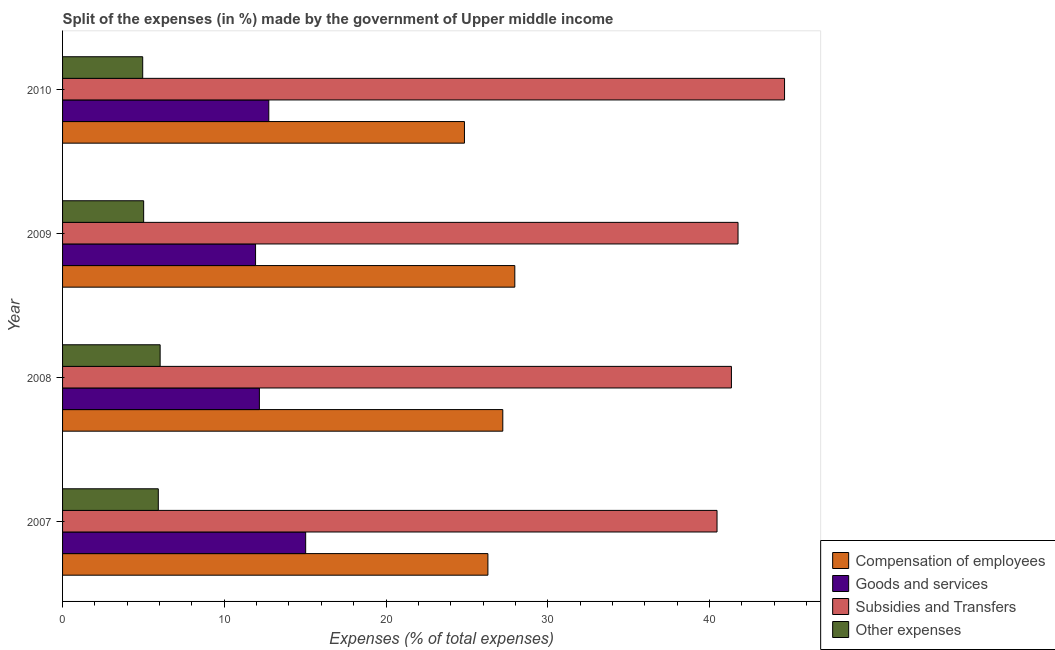How many different coloured bars are there?
Offer a terse response. 4. How many groups of bars are there?
Provide a short and direct response. 4. How many bars are there on the 2nd tick from the bottom?
Offer a terse response. 4. What is the label of the 1st group of bars from the top?
Ensure brevity in your answer.  2010. What is the percentage of amount spent on other expenses in 2008?
Ensure brevity in your answer.  6.03. Across all years, what is the maximum percentage of amount spent on compensation of employees?
Offer a very short reply. 27.96. Across all years, what is the minimum percentage of amount spent on compensation of employees?
Your response must be concise. 24.85. In which year was the percentage of amount spent on goods and services maximum?
Your answer should be very brief. 2007. What is the total percentage of amount spent on goods and services in the graph?
Provide a short and direct response. 51.89. What is the difference between the percentage of amount spent on compensation of employees in 2007 and that in 2010?
Provide a short and direct response. 1.45. What is the difference between the percentage of amount spent on goods and services in 2010 and the percentage of amount spent on other expenses in 2009?
Make the answer very short. 7.74. What is the average percentage of amount spent on compensation of employees per year?
Keep it short and to the point. 26.58. In the year 2007, what is the difference between the percentage of amount spent on goods and services and percentage of amount spent on subsidies?
Give a very brief answer. -25.43. In how many years, is the percentage of amount spent on other expenses greater than 38 %?
Provide a short and direct response. 0. What is the ratio of the percentage of amount spent on goods and services in 2008 to that in 2009?
Your response must be concise. 1.02. Is the difference between the percentage of amount spent on other expenses in 2008 and 2010 greater than the difference between the percentage of amount spent on compensation of employees in 2008 and 2010?
Your answer should be compact. No. What is the difference between the highest and the second highest percentage of amount spent on other expenses?
Give a very brief answer. 0.11. What is the difference between the highest and the lowest percentage of amount spent on compensation of employees?
Your answer should be compact. 3.11. Is the sum of the percentage of amount spent on subsidies in 2007 and 2010 greater than the maximum percentage of amount spent on other expenses across all years?
Your answer should be compact. Yes. Is it the case that in every year, the sum of the percentage of amount spent on goods and services and percentage of amount spent on subsidies is greater than the sum of percentage of amount spent on other expenses and percentage of amount spent on compensation of employees?
Provide a short and direct response. Yes. What does the 4th bar from the top in 2009 represents?
Make the answer very short. Compensation of employees. What does the 4th bar from the bottom in 2009 represents?
Offer a very short reply. Other expenses. How many bars are there?
Your answer should be very brief. 16. Does the graph contain any zero values?
Provide a short and direct response. No. Does the graph contain grids?
Your answer should be compact. No. Where does the legend appear in the graph?
Provide a succinct answer. Bottom right. How many legend labels are there?
Keep it short and to the point. 4. How are the legend labels stacked?
Provide a short and direct response. Vertical. What is the title of the graph?
Your response must be concise. Split of the expenses (in %) made by the government of Upper middle income. What is the label or title of the X-axis?
Offer a terse response. Expenses (% of total expenses). What is the Expenses (% of total expenses) of Compensation of employees in 2007?
Your response must be concise. 26.3. What is the Expenses (% of total expenses) in Goods and services in 2007?
Make the answer very short. 15.03. What is the Expenses (% of total expenses) of Subsidies and Transfers in 2007?
Your answer should be compact. 40.47. What is the Expenses (% of total expenses) in Other expenses in 2007?
Give a very brief answer. 5.92. What is the Expenses (% of total expenses) in Compensation of employees in 2008?
Keep it short and to the point. 27.22. What is the Expenses (% of total expenses) of Goods and services in 2008?
Provide a short and direct response. 12.17. What is the Expenses (% of total expenses) in Subsidies and Transfers in 2008?
Your answer should be compact. 41.36. What is the Expenses (% of total expenses) in Other expenses in 2008?
Offer a terse response. 6.03. What is the Expenses (% of total expenses) in Compensation of employees in 2009?
Offer a terse response. 27.96. What is the Expenses (% of total expenses) in Goods and services in 2009?
Make the answer very short. 11.93. What is the Expenses (% of total expenses) in Subsidies and Transfers in 2009?
Make the answer very short. 41.76. What is the Expenses (% of total expenses) of Other expenses in 2009?
Offer a terse response. 5.01. What is the Expenses (% of total expenses) of Compensation of employees in 2010?
Ensure brevity in your answer.  24.85. What is the Expenses (% of total expenses) in Goods and services in 2010?
Ensure brevity in your answer.  12.75. What is the Expenses (% of total expenses) in Subsidies and Transfers in 2010?
Your answer should be very brief. 44.64. What is the Expenses (% of total expenses) in Other expenses in 2010?
Offer a terse response. 4.96. Across all years, what is the maximum Expenses (% of total expenses) of Compensation of employees?
Offer a terse response. 27.96. Across all years, what is the maximum Expenses (% of total expenses) in Goods and services?
Give a very brief answer. 15.03. Across all years, what is the maximum Expenses (% of total expenses) in Subsidies and Transfers?
Your answer should be compact. 44.64. Across all years, what is the maximum Expenses (% of total expenses) in Other expenses?
Provide a succinct answer. 6.03. Across all years, what is the minimum Expenses (% of total expenses) of Compensation of employees?
Make the answer very short. 24.85. Across all years, what is the minimum Expenses (% of total expenses) in Goods and services?
Your answer should be compact. 11.93. Across all years, what is the minimum Expenses (% of total expenses) of Subsidies and Transfers?
Make the answer very short. 40.47. Across all years, what is the minimum Expenses (% of total expenses) of Other expenses?
Provide a short and direct response. 4.96. What is the total Expenses (% of total expenses) in Compensation of employees in the graph?
Offer a very short reply. 106.33. What is the total Expenses (% of total expenses) in Goods and services in the graph?
Ensure brevity in your answer.  51.89. What is the total Expenses (% of total expenses) of Subsidies and Transfers in the graph?
Keep it short and to the point. 168.23. What is the total Expenses (% of total expenses) in Other expenses in the graph?
Provide a short and direct response. 21.92. What is the difference between the Expenses (% of total expenses) in Compensation of employees in 2007 and that in 2008?
Ensure brevity in your answer.  -0.92. What is the difference between the Expenses (% of total expenses) of Goods and services in 2007 and that in 2008?
Your answer should be very brief. 2.86. What is the difference between the Expenses (% of total expenses) in Subsidies and Transfers in 2007 and that in 2008?
Offer a terse response. -0.89. What is the difference between the Expenses (% of total expenses) in Other expenses in 2007 and that in 2008?
Your response must be concise. -0.11. What is the difference between the Expenses (% of total expenses) of Compensation of employees in 2007 and that in 2009?
Give a very brief answer. -1.66. What is the difference between the Expenses (% of total expenses) in Goods and services in 2007 and that in 2009?
Offer a terse response. 3.1. What is the difference between the Expenses (% of total expenses) of Subsidies and Transfers in 2007 and that in 2009?
Your answer should be compact. -1.3. What is the difference between the Expenses (% of total expenses) of Other expenses in 2007 and that in 2009?
Your response must be concise. 0.91. What is the difference between the Expenses (% of total expenses) in Compensation of employees in 2007 and that in 2010?
Ensure brevity in your answer.  1.45. What is the difference between the Expenses (% of total expenses) of Goods and services in 2007 and that in 2010?
Your answer should be very brief. 2.28. What is the difference between the Expenses (% of total expenses) in Subsidies and Transfers in 2007 and that in 2010?
Offer a terse response. -4.17. What is the difference between the Expenses (% of total expenses) in Other expenses in 2007 and that in 2010?
Your answer should be compact. 0.96. What is the difference between the Expenses (% of total expenses) in Compensation of employees in 2008 and that in 2009?
Offer a very short reply. -0.74. What is the difference between the Expenses (% of total expenses) in Goods and services in 2008 and that in 2009?
Make the answer very short. 0.24. What is the difference between the Expenses (% of total expenses) in Subsidies and Transfers in 2008 and that in 2009?
Your answer should be compact. -0.41. What is the difference between the Expenses (% of total expenses) of Other expenses in 2008 and that in 2009?
Offer a terse response. 1.02. What is the difference between the Expenses (% of total expenses) of Compensation of employees in 2008 and that in 2010?
Make the answer very short. 2.37. What is the difference between the Expenses (% of total expenses) in Goods and services in 2008 and that in 2010?
Keep it short and to the point. -0.58. What is the difference between the Expenses (% of total expenses) of Subsidies and Transfers in 2008 and that in 2010?
Your answer should be very brief. -3.28. What is the difference between the Expenses (% of total expenses) in Other expenses in 2008 and that in 2010?
Provide a succinct answer. 1.08. What is the difference between the Expenses (% of total expenses) in Compensation of employees in 2009 and that in 2010?
Give a very brief answer. 3.11. What is the difference between the Expenses (% of total expenses) in Goods and services in 2009 and that in 2010?
Offer a terse response. -0.82. What is the difference between the Expenses (% of total expenses) of Subsidies and Transfers in 2009 and that in 2010?
Your answer should be very brief. -2.88. What is the difference between the Expenses (% of total expenses) in Other expenses in 2009 and that in 2010?
Ensure brevity in your answer.  0.06. What is the difference between the Expenses (% of total expenses) in Compensation of employees in 2007 and the Expenses (% of total expenses) in Goods and services in 2008?
Your answer should be very brief. 14.13. What is the difference between the Expenses (% of total expenses) of Compensation of employees in 2007 and the Expenses (% of total expenses) of Subsidies and Transfers in 2008?
Give a very brief answer. -15.06. What is the difference between the Expenses (% of total expenses) of Compensation of employees in 2007 and the Expenses (% of total expenses) of Other expenses in 2008?
Make the answer very short. 20.27. What is the difference between the Expenses (% of total expenses) in Goods and services in 2007 and the Expenses (% of total expenses) in Subsidies and Transfers in 2008?
Offer a very short reply. -26.32. What is the difference between the Expenses (% of total expenses) in Goods and services in 2007 and the Expenses (% of total expenses) in Other expenses in 2008?
Give a very brief answer. 9. What is the difference between the Expenses (% of total expenses) in Subsidies and Transfers in 2007 and the Expenses (% of total expenses) in Other expenses in 2008?
Your answer should be very brief. 34.43. What is the difference between the Expenses (% of total expenses) of Compensation of employees in 2007 and the Expenses (% of total expenses) of Goods and services in 2009?
Make the answer very short. 14.37. What is the difference between the Expenses (% of total expenses) in Compensation of employees in 2007 and the Expenses (% of total expenses) in Subsidies and Transfers in 2009?
Make the answer very short. -15.46. What is the difference between the Expenses (% of total expenses) of Compensation of employees in 2007 and the Expenses (% of total expenses) of Other expenses in 2009?
Provide a short and direct response. 21.28. What is the difference between the Expenses (% of total expenses) of Goods and services in 2007 and the Expenses (% of total expenses) of Subsidies and Transfers in 2009?
Offer a terse response. -26.73. What is the difference between the Expenses (% of total expenses) of Goods and services in 2007 and the Expenses (% of total expenses) of Other expenses in 2009?
Provide a short and direct response. 10.02. What is the difference between the Expenses (% of total expenses) in Subsidies and Transfers in 2007 and the Expenses (% of total expenses) in Other expenses in 2009?
Provide a short and direct response. 35.45. What is the difference between the Expenses (% of total expenses) of Compensation of employees in 2007 and the Expenses (% of total expenses) of Goods and services in 2010?
Your response must be concise. 13.55. What is the difference between the Expenses (% of total expenses) in Compensation of employees in 2007 and the Expenses (% of total expenses) in Subsidies and Transfers in 2010?
Your answer should be compact. -18.34. What is the difference between the Expenses (% of total expenses) in Compensation of employees in 2007 and the Expenses (% of total expenses) in Other expenses in 2010?
Offer a terse response. 21.34. What is the difference between the Expenses (% of total expenses) in Goods and services in 2007 and the Expenses (% of total expenses) in Subsidies and Transfers in 2010?
Offer a very short reply. -29.61. What is the difference between the Expenses (% of total expenses) in Goods and services in 2007 and the Expenses (% of total expenses) in Other expenses in 2010?
Provide a short and direct response. 10.08. What is the difference between the Expenses (% of total expenses) of Subsidies and Transfers in 2007 and the Expenses (% of total expenses) of Other expenses in 2010?
Your answer should be compact. 35.51. What is the difference between the Expenses (% of total expenses) of Compensation of employees in 2008 and the Expenses (% of total expenses) of Goods and services in 2009?
Keep it short and to the point. 15.29. What is the difference between the Expenses (% of total expenses) of Compensation of employees in 2008 and the Expenses (% of total expenses) of Subsidies and Transfers in 2009?
Give a very brief answer. -14.54. What is the difference between the Expenses (% of total expenses) in Compensation of employees in 2008 and the Expenses (% of total expenses) in Other expenses in 2009?
Offer a very short reply. 22.21. What is the difference between the Expenses (% of total expenses) of Goods and services in 2008 and the Expenses (% of total expenses) of Subsidies and Transfers in 2009?
Your answer should be very brief. -29.59. What is the difference between the Expenses (% of total expenses) of Goods and services in 2008 and the Expenses (% of total expenses) of Other expenses in 2009?
Offer a terse response. 7.16. What is the difference between the Expenses (% of total expenses) in Subsidies and Transfers in 2008 and the Expenses (% of total expenses) in Other expenses in 2009?
Ensure brevity in your answer.  36.34. What is the difference between the Expenses (% of total expenses) in Compensation of employees in 2008 and the Expenses (% of total expenses) in Goods and services in 2010?
Offer a very short reply. 14.47. What is the difference between the Expenses (% of total expenses) in Compensation of employees in 2008 and the Expenses (% of total expenses) in Subsidies and Transfers in 2010?
Your response must be concise. -17.42. What is the difference between the Expenses (% of total expenses) in Compensation of employees in 2008 and the Expenses (% of total expenses) in Other expenses in 2010?
Make the answer very short. 22.27. What is the difference between the Expenses (% of total expenses) of Goods and services in 2008 and the Expenses (% of total expenses) of Subsidies and Transfers in 2010?
Provide a succinct answer. -32.47. What is the difference between the Expenses (% of total expenses) of Goods and services in 2008 and the Expenses (% of total expenses) of Other expenses in 2010?
Offer a terse response. 7.21. What is the difference between the Expenses (% of total expenses) of Subsidies and Transfers in 2008 and the Expenses (% of total expenses) of Other expenses in 2010?
Provide a short and direct response. 36.4. What is the difference between the Expenses (% of total expenses) in Compensation of employees in 2009 and the Expenses (% of total expenses) in Goods and services in 2010?
Offer a very short reply. 15.21. What is the difference between the Expenses (% of total expenses) in Compensation of employees in 2009 and the Expenses (% of total expenses) in Subsidies and Transfers in 2010?
Your response must be concise. -16.68. What is the difference between the Expenses (% of total expenses) in Compensation of employees in 2009 and the Expenses (% of total expenses) in Other expenses in 2010?
Offer a very short reply. 23.01. What is the difference between the Expenses (% of total expenses) of Goods and services in 2009 and the Expenses (% of total expenses) of Subsidies and Transfers in 2010?
Ensure brevity in your answer.  -32.71. What is the difference between the Expenses (% of total expenses) of Goods and services in 2009 and the Expenses (% of total expenses) of Other expenses in 2010?
Ensure brevity in your answer.  6.98. What is the difference between the Expenses (% of total expenses) of Subsidies and Transfers in 2009 and the Expenses (% of total expenses) of Other expenses in 2010?
Offer a very short reply. 36.81. What is the average Expenses (% of total expenses) in Compensation of employees per year?
Your answer should be compact. 26.58. What is the average Expenses (% of total expenses) of Goods and services per year?
Provide a succinct answer. 12.97. What is the average Expenses (% of total expenses) in Subsidies and Transfers per year?
Ensure brevity in your answer.  42.06. What is the average Expenses (% of total expenses) in Other expenses per year?
Your response must be concise. 5.48. In the year 2007, what is the difference between the Expenses (% of total expenses) in Compensation of employees and Expenses (% of total expenses) in Goods and services?
Ensure brevity in your answer.  11.27. In the year 2007, what is the difference between the Expenses (% of total expenses) in Compensation of employees and Expenses (% of total expenses) in Subsidies and Transfers?
Ensure brevity in your answer.  -14.17. In the year 2007, what is the difference between the Expenses (% of total expenses) of Compensation of employees and Expenses (% of total expenses) of Other expenses?
Your response must be concise. 20.38. In the year 2007, what is the difference between the Expenses (% of total expenses) of Goods and services and Expenses (% of total expenses) of Subsidies and Transfers?
Your response must be concise. -25.43. In the year 2007, what is the difference between the Expenses (% of total expenses) in Goods and services and Expenses (% of total expenses) in Other expenses?
Offer a very short reply. 9.11. In the year 2007, what is the difference between the Expenses (% of total expenses) of Subsidies and Transfers and Expenses (% of total expenses) of Other expenses?
Keep it short and to the point. 34.55. In the year 2008, what is the difference between the Expenses (% of total expenses) of Compensation of employees and Expenses (% of total expenses) of Goods and services?
Provide a succinct answer. 15.05. In the year 2008, what is the difference between the Expenses (% of total expenses) of Compensation of employees and Expenses (% of total expenses) of Subsidies and Transfers?
Provide a succinct answer. -14.14. In the year 2008, what is the difference between the Expenses (% of total expenses) in Compensation of employees and Expenses (% of total expenses) in Other expenses?
Keep it short and to the point. 21.19. In the year 2008, what is the difference between the Expenses (% of total expenses) in Goods and services and Expenses (% of total expenses) in Subsidies and Transfers?
Provide a short and direct response. -29.19. In the year 2008, what is the difference between the Expenses (% of total expenses) of Goods and services and Expenses (% of total expenses) of Other expenses?
Your response must be concise. 6.14. In the year 2008, what is the difference between the Expenses (% of total expenses) in Subsidies and Transfers and Expenses (% of total expenses) in Other expenses?
Offer a very short reply. 35.32. In the year 2009, what is the difference between the Expenses (% of total expenses) of Compensation of employees and Expenses (% of total expenses) of Goods and services?
Offer a terse response. 16.03. In the year 2009, what is the difference between the Expenses (% of total expenses) in Compensation of employees and Expenses (% of total expenses) in Subsidies and Transfers?
Make the answer very short. -13.8. In the year 2009, what is the difference between the Expenses (% of total expenses) in Compensation of employees and Expenses (% of total expenses) in Other expenses?
Offer a terse response. 22.95. In the year 2009, what is the difference between the Expenses (% of total expenses) of Goods and services and Expenses (% of total expenses) of Subsidies and Transfers?
Provide a succinct answer. -29.83. In the year 2009, what is the difference between the Expenses (% of total expenses) in Goods and services and Expenses (% of total expenses) in Other expenses?
Make the answer very short. 6.92. In the year 2009, what is the difference between the Expenses (% of total expenses) in Subsidies and Transfers and Expenses (% of total expenses) in Other expenses?
Your response must be concise. 36.75. In the year 2010, what is the difference between the Expenses (% of total expenses) in Compensation of employees and Expenses (% of total expenses) in Goods and services?
Your response must be concise. 12.1. In the year 2010, what is the difference between the Expenses (% of total expenses) of Compensation of employees and Expenses (% of total expenses) of Subsidies and Transfers?
Keep it short and to the point. -19.79. In the year 2010, what is the difference between the Expenses (% of total expenses) in Compensation of employees and Expenses (% of total expenses) in Other expenses?
Make the answer very short. 19.89. In the year 2010, what is the difference between the Expenses (% of total expenses) in Goods and services and Expenses (% of total expenses) in Subsidies and Transfers?
Give a very brief answer. -31.89. In the year 2010, what is the difference between the Expenses (% of total expenses) of Goods and services and Expenses (% of total expenses) of Other expenses?
Make the answer very short. 7.8. In the year 2010, what is the difference between the Expenses (% of total expenses) of Subsidies and Transfers and Expenses (% of total expenses) of Other expenses?
Offer a very short reply. 39.69. What is the ratio of the Expenses (% of total expenses) of Compensation of employees in 2007 to that in 2008?
Offer a terse response. 0.97. What is the ratio of the Expenses (% of total expenses) of Goods and services in 2007 to that in 2008?
Provide a succinct answer. 1.24. What is the ratio of the Expenses (% of total expenses) of Subsidies and Transfers in 2007 to that in 2008?
Provide a succinct answer. 0.98. What is the ratio of the Expenses (% of total expenses) of Other expenses in 2007 to that in 2008?
Make the answer very short. 0.98. What is the ratio of the Expenses (% of total expenses) in Compensation of employees in 2007 to that in 2009?
Provide a succinct answer. 0.94. What is the ratio of the Expenses (% of total expenses) of Goods and services in 2007 to that in 2009?
Your answer should be very brief. 1.26. What is the ratio of the Expenses (% of total expenses) of Subsidies and Transfers in 2007 to that in 2009?
Ensure brevity in your answer.  0.97. What is the ratio of the Expenses (% of total expenses) of Other expenses in 2007 to that in 2009?
Your answer should be very brief. 1.18. What is the ratio of the Expenses (% of total expenses) in Compensation of employees in 2007 to that in 2010?
Your answer should be very brief. 1.06. What is the ratio of the Expenses (% of total expenses) of Goods and services in 2007 to that in 2010?
Ensure brevity in your answer.  1.18. What is the ratio of the Expenses (% of total expenses) in Subsidies and Transfers in 2007 to that in 2010?
Your answer should be compact. 0.91. What is the ratio of the Expenses (% of total expenses) in Other expenses in 2007 to that in 2010?
Ensure brevity in your answer.  1.19. What is the ratio of the Expenses (% of total expenses) in Compensation of employees in 2008 to that in 2009?
Your response must be concise. 0.97. What is the ratio of the Expenses (% of total expenses) of Goods and services in 2008 to that in 2009?
Make the answer very short. 1.02. What is the ratio of the Expenses (% of total expenses) in Subsidies and Transfers in 2008 to that in 2009?
Provide a succinct answer. 0.99. What is the ratio of the Expenses (% of total expenses) in Other expenses in 2008 to that in 2009?
Your answer should be very brief. 1.2. What is the ratio of the Expenses (% of total expenses) of Compensation of employees in 2008 to that in 2010?
Give a very brief answer. 1.1. What is the ratio of the Expenses (% of total expenses) of Goods and services in 2008 to that in 2010?
Provide a short and direct response. 0.95. What is the ratio of the Expenses (% of total expenses) in Subsidies and Transfers in 2008 to that in 2010?
Make the answer very short. 0.93. What is the ratio of the Expenses (% of total expenses) of Other expenses in 2008 to that in 2010?
Provide a succinct answer. 1.22. What is the ratio of the Expenses (% of total expenses) of Compensation of employees in 2009 to that in 2010?
Give a very brief answer. 1.13. What is the ratio of the Expenses (% of total expenses) of Goods and services in 2009 to that in 2010?
Make the answer very short. 0.94. What is the ratio of the Expenses (% of total expenses) in Subsidies and Transfers in 2009 to that in 2010?
Your answer should be very brief. 0.94. What is the ratio of the Expenses (% of total expenses) in Other expenses in 2009 to that in 2010?
Offer a terse response. 1.01. What is the difference between the highest and the second highest Expenses (% of total expenses) in Compensation of employees?
Your answer should be compact. 0.74. What is the difference between the highest and the second highest Expenses (% of total expenses) of Goods and services?
Ensure brevity in your answer.  2.28. What is the difference between the highest and the second highest Expenses (% of total expenses) of Subsidies and Transfers?
Keep it short and to the point. 2.88. What is the difference between the highest and the second highest Expenses (% of total expenses) of Other expenses?
Offer a very short reply. 0.11. What is the difference between the highest and the lowest Expenses (% of total expenses) of Compensation of employees?
Your answer should be compact. 3.11. What is the difference between the highest and the lowest Expenses (% of total expenses) in Goods and services?
Make the answer very short. 3.1. What is the difference between the highest and the lowest Expenses (% of total expenses) in Subsidies and Transfers?
Make the answer very short. 4.17. What is the difference between the highest and the lowest Expenses (% of total expenses) in Other expenses?
Ensure brevity in your answer.  1.08. 